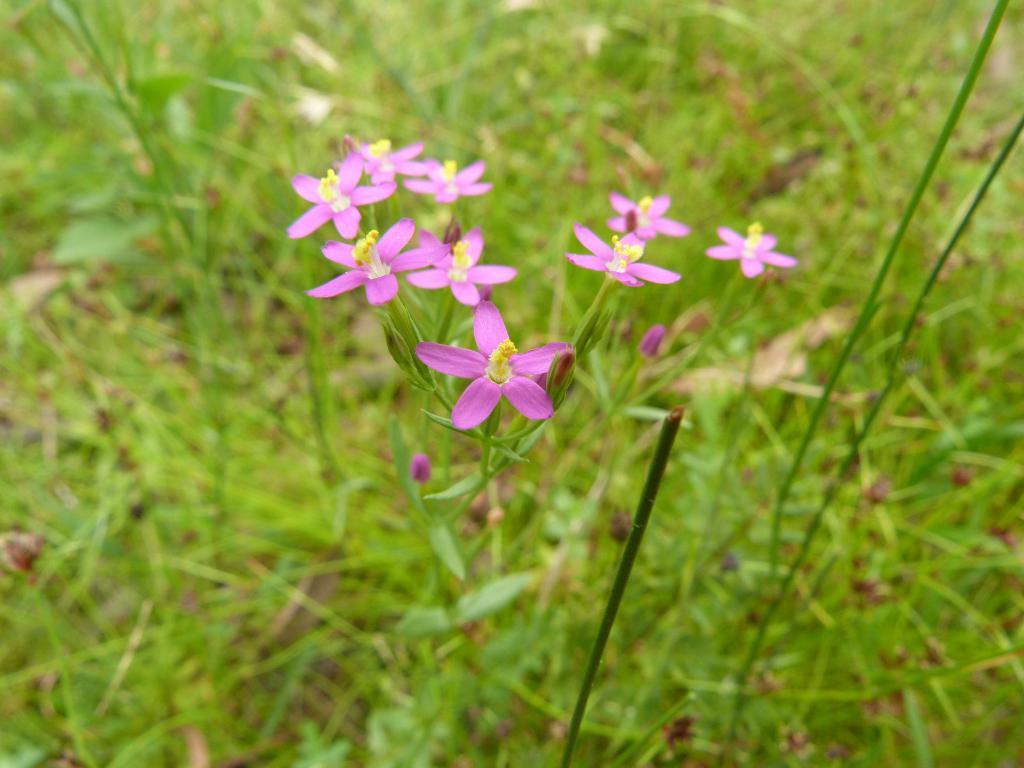How would you summarize this image in a sentence or two? This picture is clicked outside. In the center we can see the group of flowers and the green grass. 